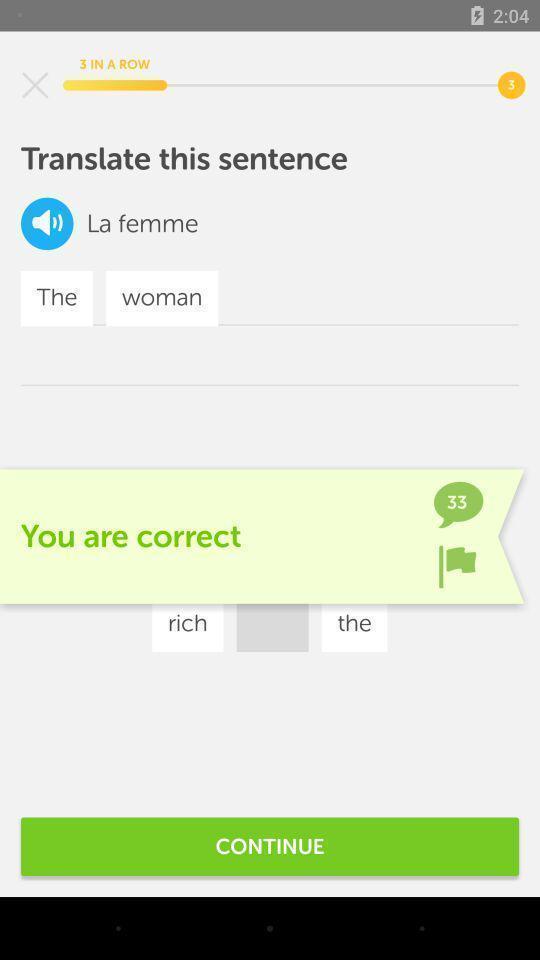Please provide a description for this image. Page showing translation of language. 